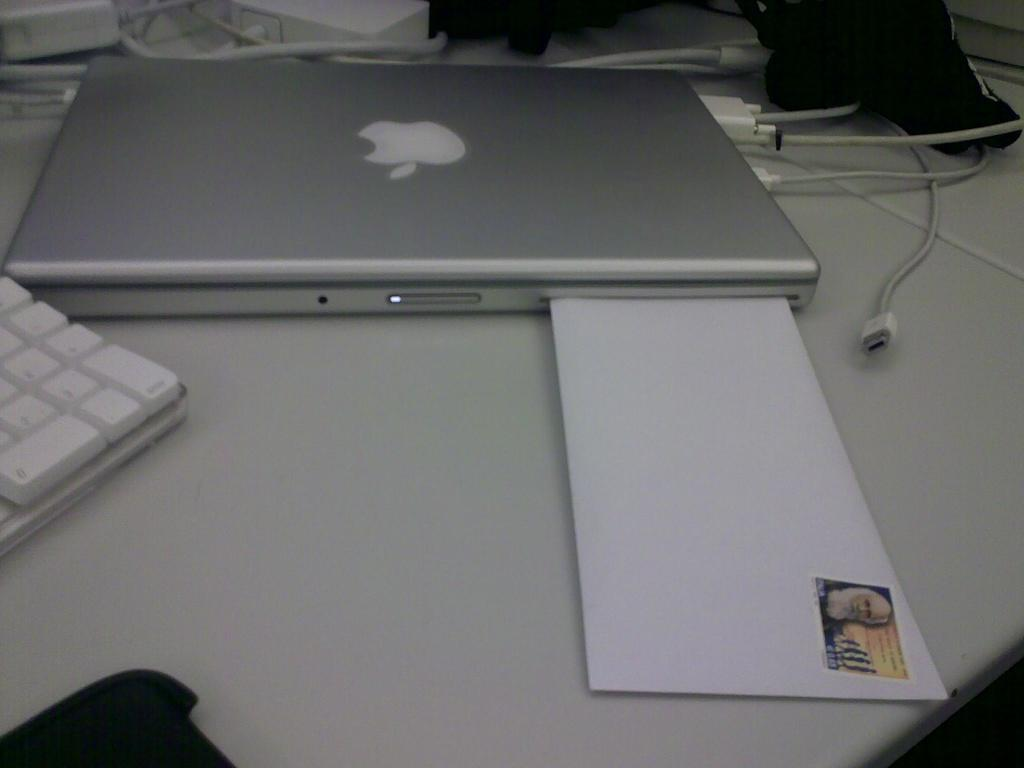What is the main object in the middle of the image? There is a table in the middle of the image. What items can be seen on the table? Cables, a laptop, a keyboard, an envelope, a stamp, and a cloth are on the table. What type of electronic device is on the table? There is a laptop on the table. What might be used for typing on the laptop? A keyboard is on the table for typing. Where is the garden located in the image? There is no garden present in the image; it features a table with various items on it. What type of club is visible in the image? There is no club present in the image. 